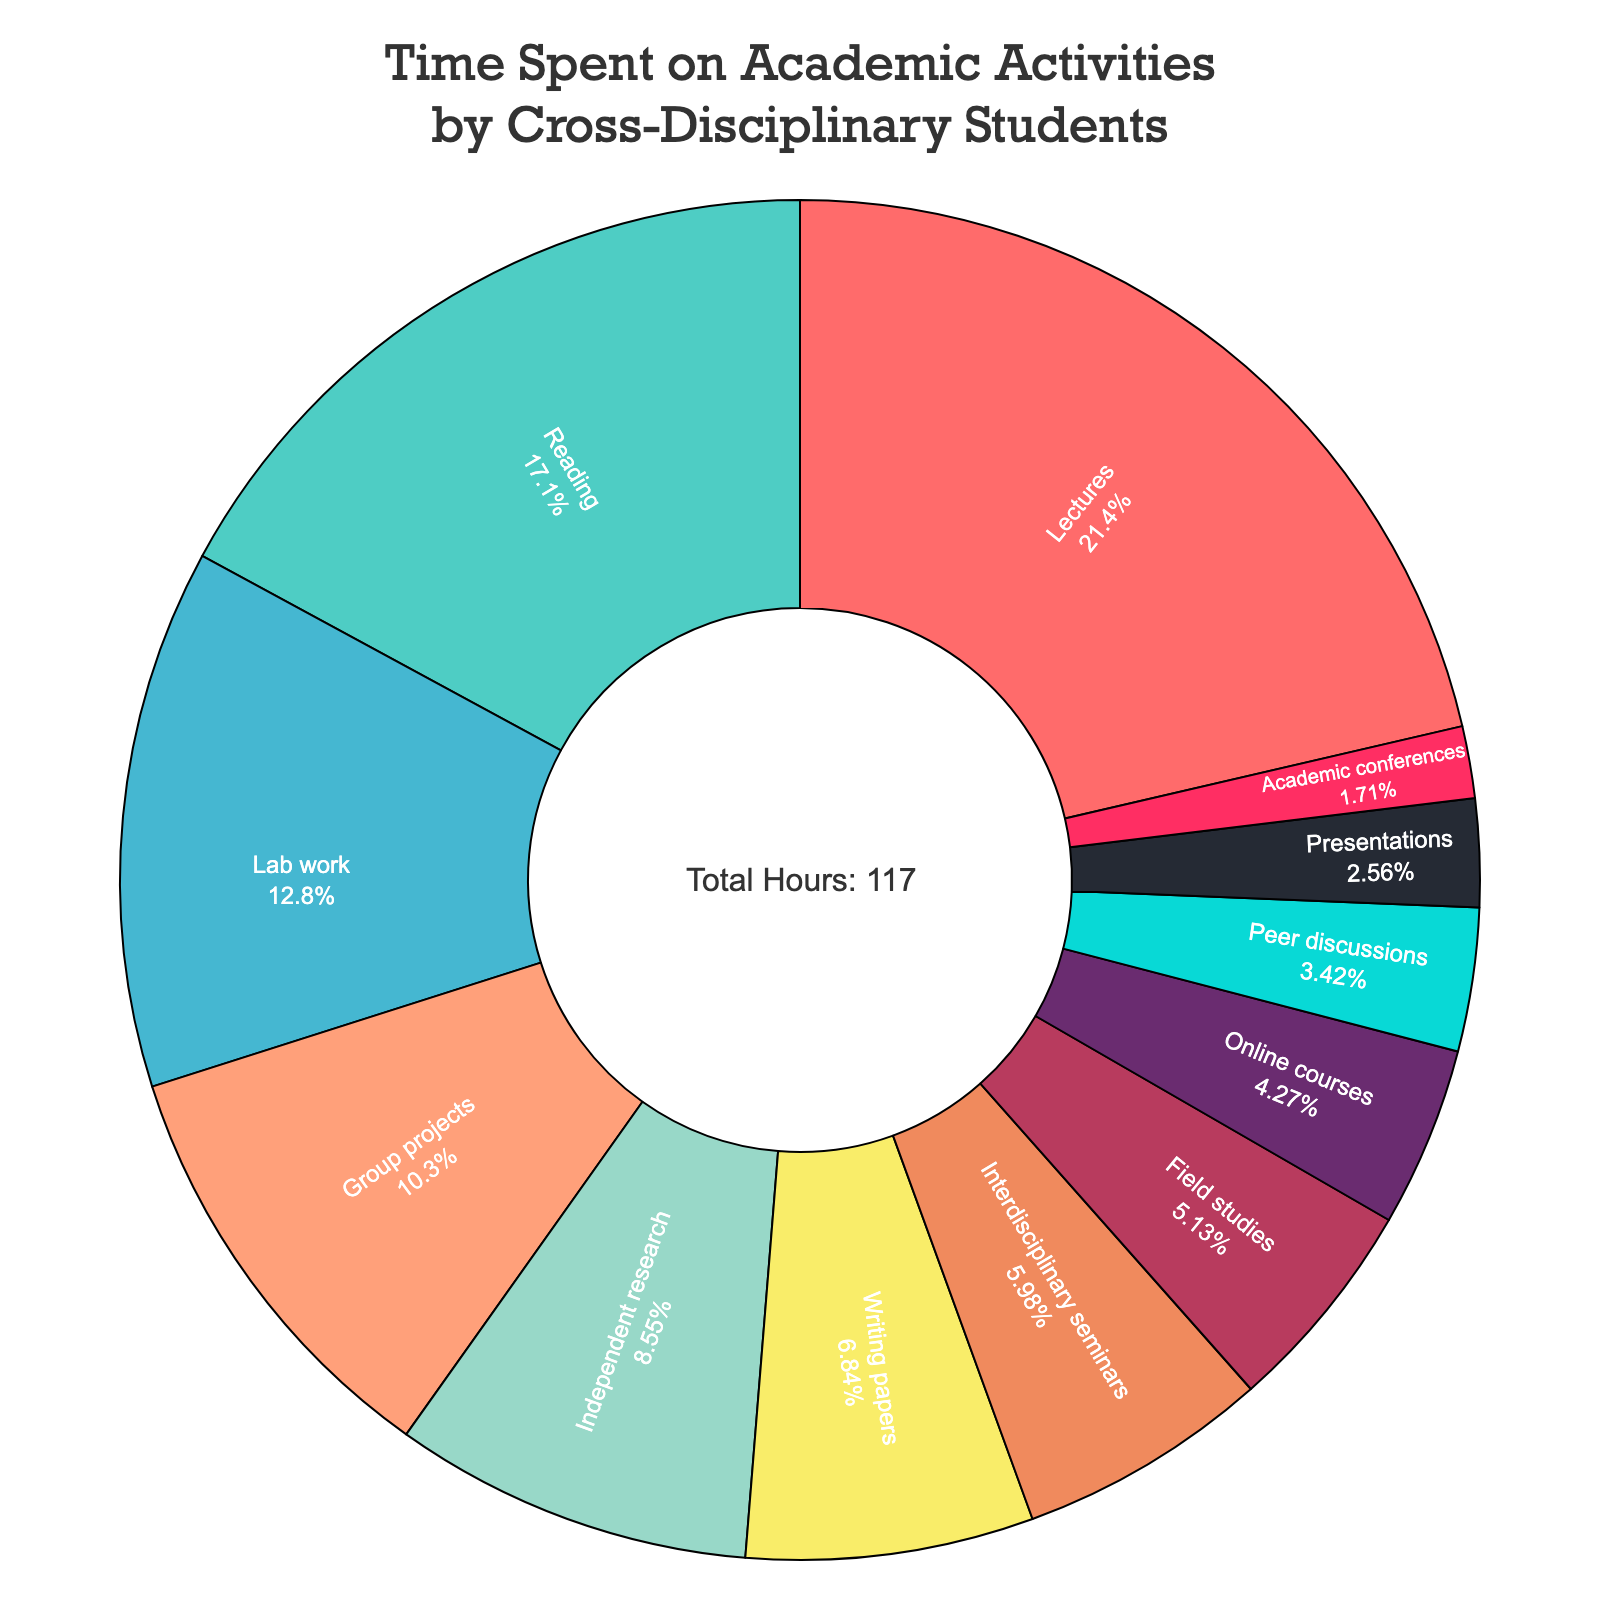What activity takes up the most time for cross-disciplinary students? The pie chart shows the time distribution across different activities, and the activity with the largest segment visually represents the one that takes up the most time. Lectures have the largest segment.
Answer: Lectures What is the combined time spent on reading and lab work? The hours spent on reading and lab work are shown in distinct segments. Reading accounts for 20 hours, and lab work accounts for 15 hours. Adding these together: 20 + 15 = 35 hours.
Answer: 35 hours How does the time spent on interdisciplinary seminars compare to the time spent on online courses? By examining the pie chart, the segment for interdisciplinary seminars is larger than the segment for online courses. Specifically, interdisciplinary seminars account for 7 hours, whereas online courses account for 5 hours.
Answer: Interdisciplinary seminars: 7 hours, Online courses: 5 hours What percentage of time is spent on group projects relative to the total time? The total number of hours is annotated in the center as 117 hours. The time spent on group projects is 12 hours. The percentage is calculated as (12 / 117) * 100 ≈ 10.26%.
Answer: Approximately 10.26% Which activity has the least amount of time spent on it? The activity with the smallest segment in the pie chart represents the least amount of time spent. The smallest segment is for academic conferences, which accounts for 2 hours.
Answer: Academic conferences How many more hours are spent on lectures compared to writing papers? The pie chart indicates that lectures account for 25 hours and writing papers account for 8 hours. The difference is calculated as 25 - 8 = 17 hours.
Answer: 17 hours What is the total time spent on independent research and presentations? The hours allocated to independent research and presentations are shown in the pie chart. Independent research is 10 hours, and presentations are 3 hours. Adding these together: 10 + 3 = 13 hours.
Answer: 13 hours Which activity is represented by the blue segment? The pie chart uses different colors for each activity. The segment colored blue corresponds to one of the activities. By matching the blue segment visually with the label, we identify it as reading.
Answer: Reading Is the time spent on field studies greater than the time spent on peer discussions? The pie chart shows different segments for each activity. Field studies account for 6 hours while peer discussions account for 4 hours. Field studies have more hours than peer discussions.
Answer: Yes What is the difference in time spent between the most time-consuming and least time-consuming activities? The pie chart shows that lectures take the most time (25 hours) and academic conferences take the least (2 hours). The difference is calculated as 25 - 2 = 23 hours.
Answer: 23 hours 